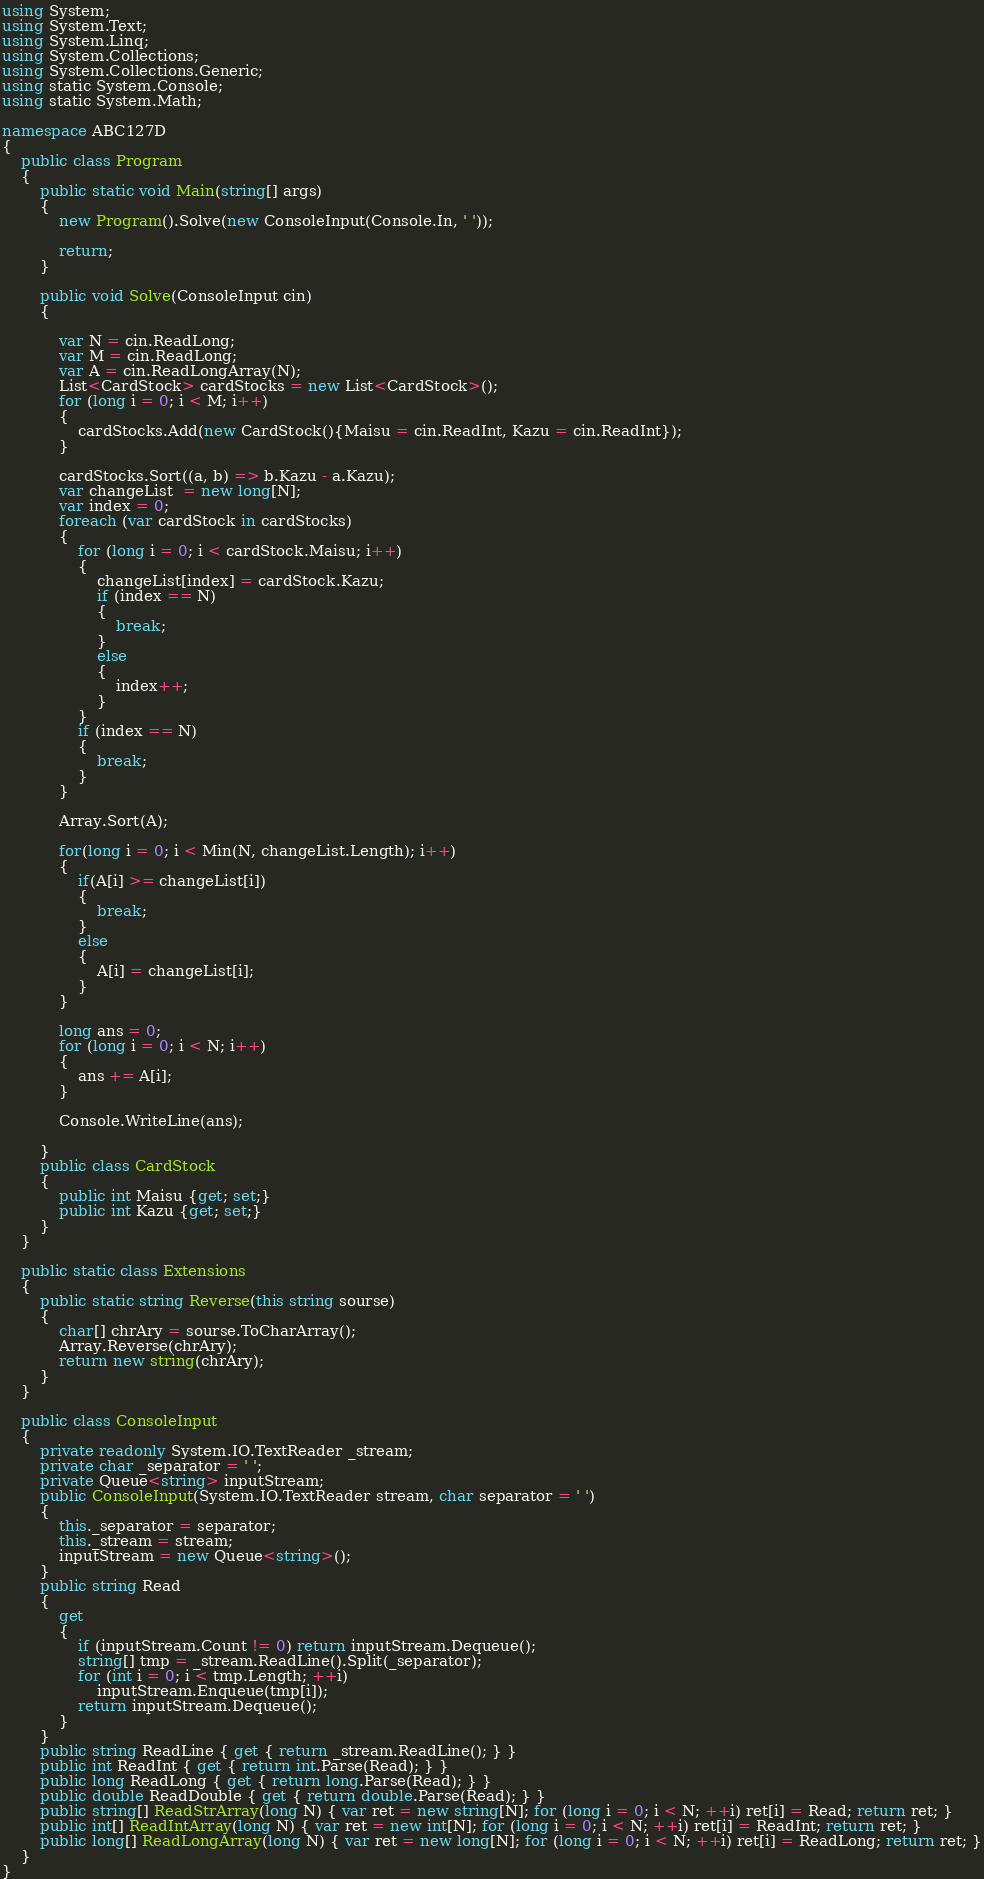Convert code to text. <code><loc_0><loc_0><loc_500><loc_500><_C#_>using System;
using System.Text;
using System.Linq;
using System.Collections;
using System.Collections.Generic;
using static System.Console;
using static System.Math;

namespace ABC127D
{
    public class Program
    {
        public static void Main(string[] args)
        {
            new Program().Solve(new ConsoleInput(Console.In, ' '));

            return;
        }

        public void Solve(ConsoleInput cin)
        {

            var N = cin.ReadLong;
            var M = cin.ReadLong;
            var A = cin.ReadLongArray(N);
            List<CardStock> cardStocks = new List<CardStock>();
            for (long i = 0; i < M; i++)
            {
                cardStocks.Add(new CardStock(){Maisu = cin.ReadInt, Kazu = cin.ReadInt});
            }

            cardStocks.Sort((a, b) => b.Kazu - a.Kazu);
            var changeList  = new long[N];
            var index = 0;
            foreach (var cardStock in cardStocks)
            {
                for (long i = 0; i < cardStock.Maisu; i++)
                {
                    changeList[index] = cardStock.Kazu;
                    if (index == N)
                    {
                        break;
                    }
                    else
                    {
                        index++;
                    }
                }
                if (index == N)
                {
                    break;
                }
            }

            Array.Sort(A);

            for(long i = 0; i < Min(N, changeList.Length); i++)
            {
                if(A[i] >= changeList[i])
                {
                    break;
                }
                else
                {
                    A[i] = changeList[i];
                }
            }

            long ans = 0;
            for (long i = 0; i < N; i++)
            {
                ans += A[i];
            }

            Console.WriteLine(ans);

        }
        public class CardStock
        {
            public int Maisu {get; set;}
            public int Kazu {get; set;}
        }
    }

    public static class Extensions
    {
        public static string Reverse(this string sourse)
        {
            char[] chrAry = sourse.ToCharArray();
            Array.Reverse(chrAry);
            return new string(chrAry);
        }
    }

    public class ConsoleInput
    {
        private readonly System.IO.TextReader _stream;
        private char _separator = ' ';
        private Queue<string> inputStream;
        public ConsoleInput(System.IO.TextReader stream, char separator = ' ')
        {
            this._separator = separator;
            this._stream = stream;
            inputStream = new Queue<string>();
        }
        public string Read
        {
            get
            {
                if (inputStream.Count != 0) return inputStream.Dequeue();
                string[] tmp = _stream.ReadLine().Split(_separator);
                for (int i = 0; i < tmp.Length; ++i)
                    inputStream.Enqueue(tmp[i]);
                return inputStream.Dequeue();
            }
        }
        public string ReadLine { get { return _stream.ReadLine(); } }
        public int ReadInt { get { return int.Parse(Read); } }
        public long ReadLong { get { return long.Parse(Read); } }
        public double ReadDouble { get { return double.Parse(Read); } }
        public string[] ReadStrArray(long N) { var ret = new string[N]; for (long i = 0; i < N; ++i) ret[i] = Read; return ret; }
        public int[] ReadIntArray(long N) { var ret = new int[N]; for (long i = 0; i < N; ++i) ret[i] = ReadInt; return ret; }
        public long[] ReadLongArray(long N) { var ret = new long[N]; for (long i = 0; i < N; ++i) ret[i] = ReadLong; return ret; }
    }
}
</code> 